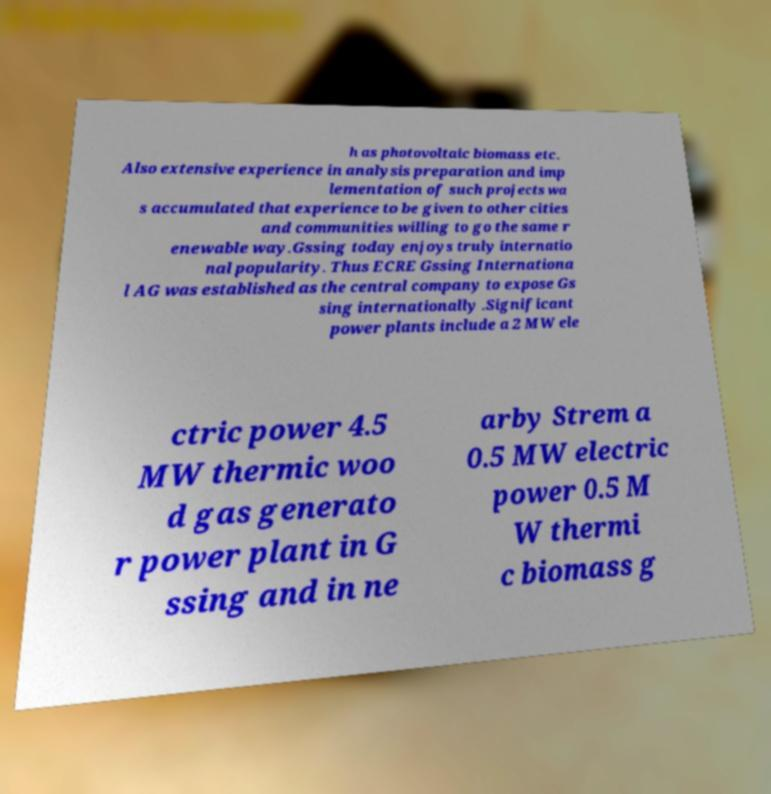Can you accurately transcribe the text from the provided image for me? h as photovoltaic biomass etc. Also extensive experience in analysis preparation and imp lementation of such projects wa s accumulated that experience to be given to other cities and communities willing to go the same r enewable way.Gssing today enjoys truly internatio nal popularity. Thus ECRE Gssing Internationa l AG was established as the central company to expose Gs sing internationally .Significant power plants include a 2 MW ele ctric power 4.5 MW thermic woo d gas generato r power plant in G ssing and in ne arby Strem a 0.5 MW electric power 0.5 M W thermi c biomass g 